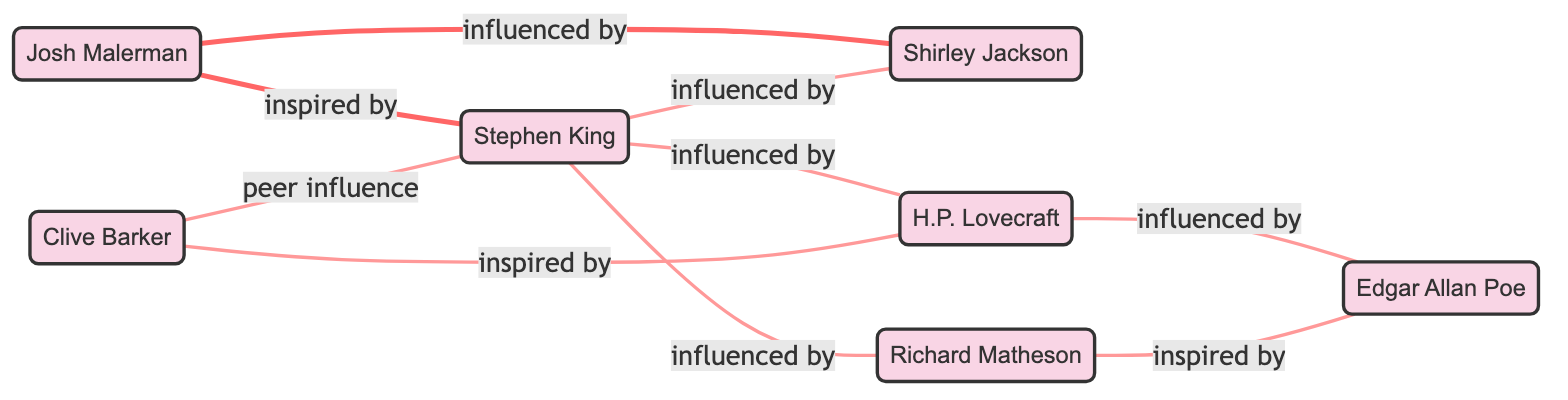What is the total number of nodes in this social network of horror authors? By counting the unique authors listed in the nodes section of the diagram data, I find that there are 7 nodes: Josh Malerman, Stephen King, Shirley Jackson, H.P. Lovecraft, Edgar Allan Poe, Richard Matheson, and Clive Barker.
Answer: 7 Who is inspired by H.P. Lovecraft in this diagram? I examine the edges connected to the node representing H.P. Lovecraft. There is one edge that indicates Clive Barker is inspired by H.P. Lovecraft.
Answer: Clive Barker Which author has the most incoming influences? I review the edges directed towards each author to count how many times they are influenced by others. Stephen King has 3 incoming influences from H.P. Lovecraft, Richard Matheson, and Shirley Jackson, which is the highest count among the authors.
Answer: Stephen King How many authors are directly influenced by Shirley Jackson? Looking at the edges pointing from Shirley Jackson, I find no authors being influenced by her directly. Hence, the count is zero.
Answer: 0 Which two authors have a peer influence relationship? I analyze the connections in the diagram and see that the edge labeled "peer influence" exists between Clive Barker and Stephen King.
Answer: Clive Barker and Stephen King Is there a direct influence connection from Richard Matheson to Stephen King? Checking the edges, I find that there is no direct influence from Richard Matheson to Stephen King; instead, Richard Matheson influences Edgar Allan Poe.
Answer: No Identify the author influenced by Edgar Allan Poe. In the edges section, I see that Richard Matheson is indicated as inspired by Edgar Allan Poe, making him the author that connects to Poe.
Answer: Richard Matheson Who is influenced by both Stephen King and Shirley Jackson? Analyzing the diagram, I find no author with direct connections from both Stephen King and Shirley Jackson; the only connections are singularly to different authors. Therefore, the answer is that no author fits this criterion.
Answer: No How is Josh Malerman connected to the other authors? I look at the edges connected to Josh Malerman, which indicates he is inspired by Stephen King and influenced by Shirley Jackson, forming two distinct relationships.
Answer: Inspired by Stephen King, influenced by Shirley Jackson 